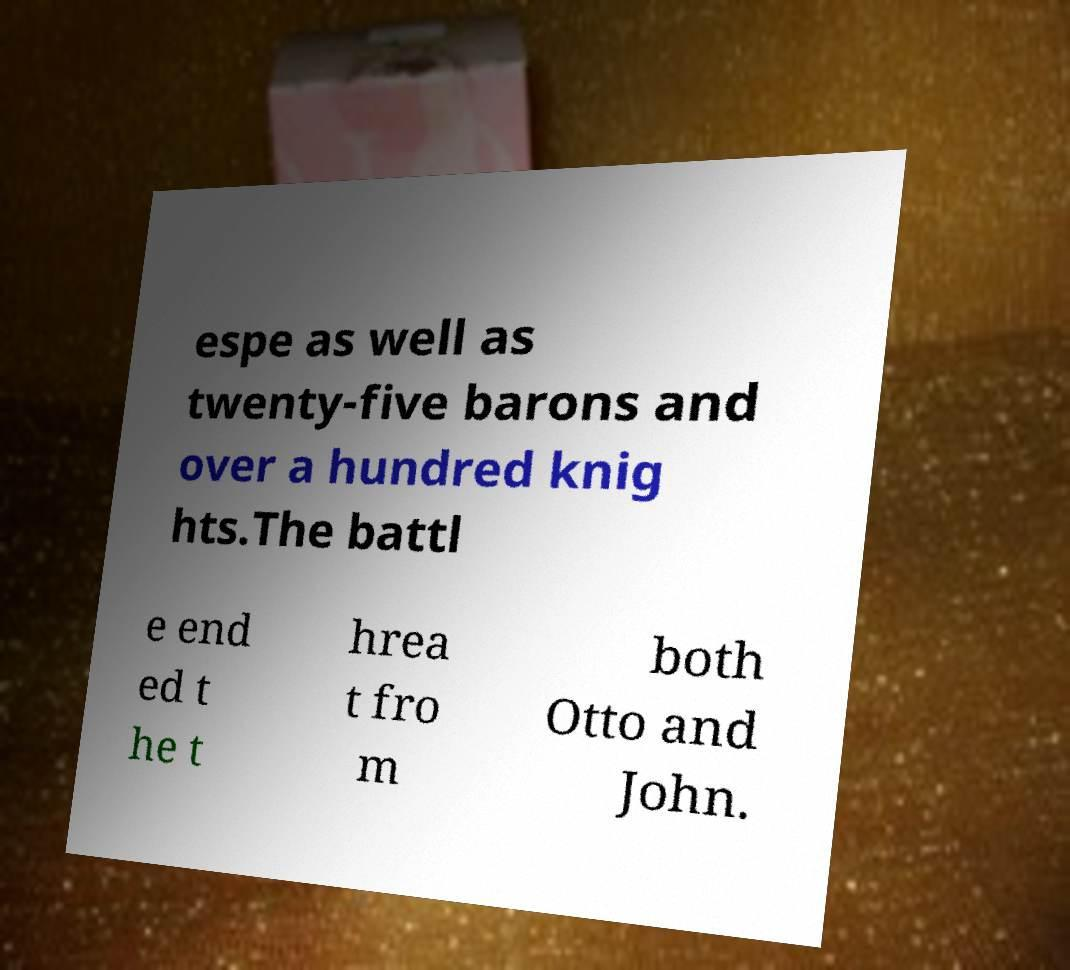Could you assist in decoding the text presented in this image and type it out clearly? espe as well as twenty-five barons and over a hundred knig hts.The battl e end ed t he t hrea t fro m both Otto and John. 